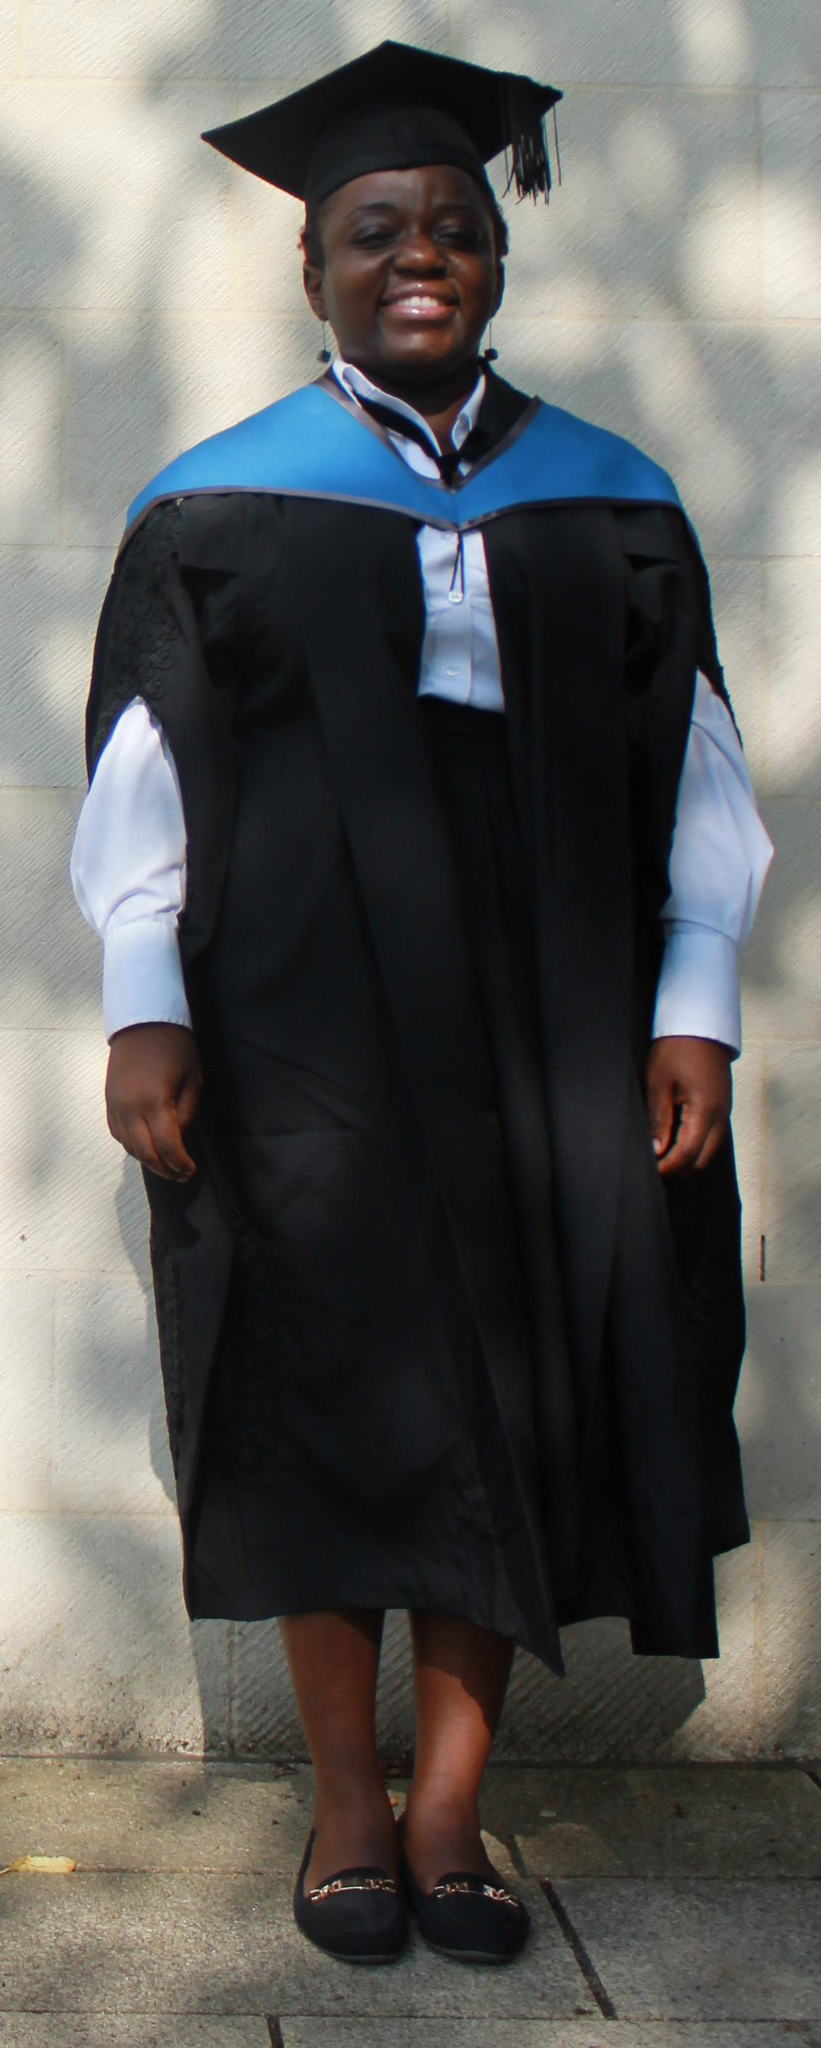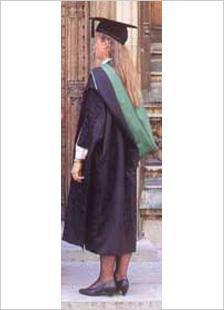The first image is the image on the left, the second image is the image on the right. Considering the images on both sides, is "In the right image, the tassle of a graduate's hat is on the left side of the image." valid? Answer yes or no. Yes. The first image is the image on the left, the second image is the image on the right. For the images displayed, is the sentence "An image shows only one person modeling graduation attire, a long-haired female who is not facing the camera." factually correct? Answer yes or no. Yes. The first image is the image on the left, the second image is the image on the right. Evaluate the accuracy of this statement regarding the images: "Each image contains one female graduate, and one image shows a graduate who is not facing forward.". Is it true? Answer yes or no. Yes. The first image is the image on the left, the second image is the image on the right. Evaluate the accuracy of this statement regarding the images: "An image contains more than one graduation student.". Is it true? Answer yes or no. No. 